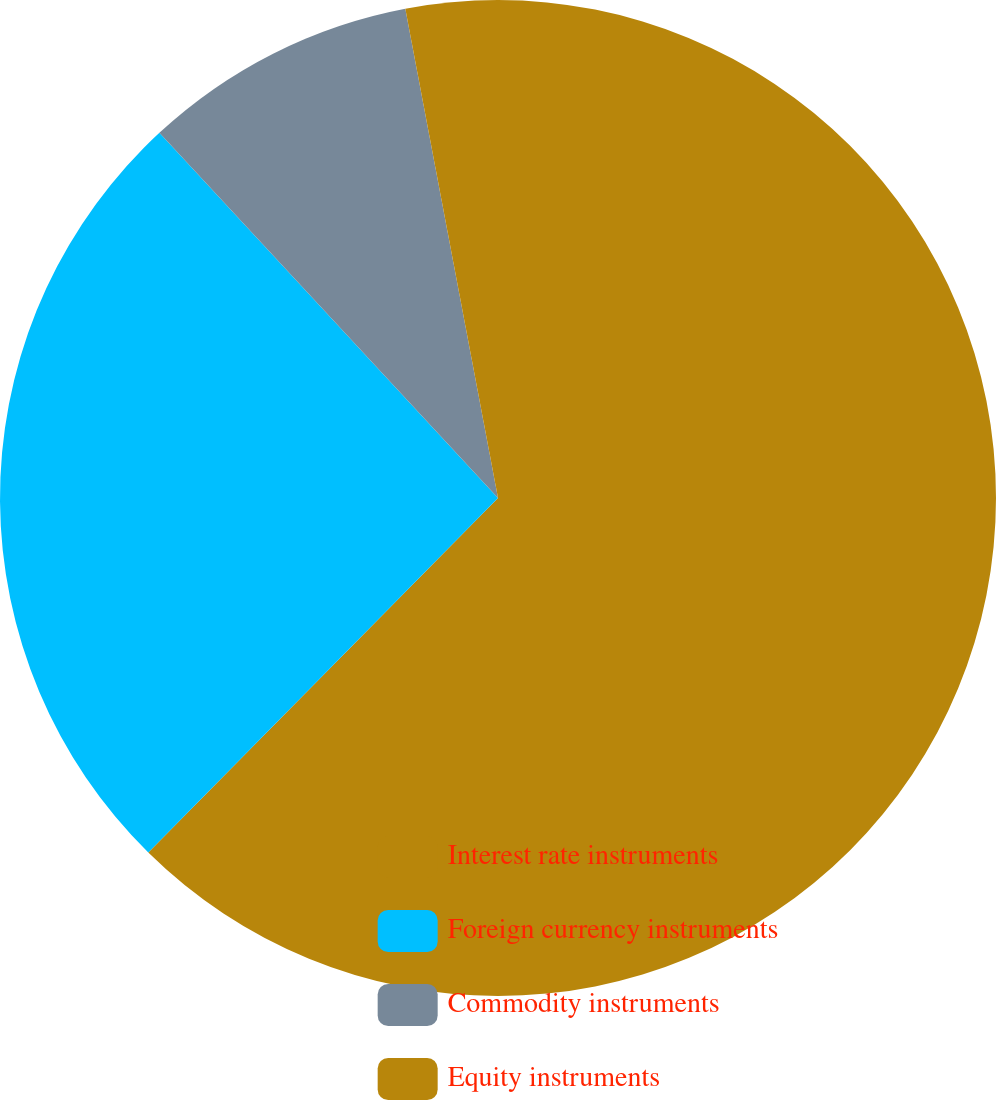Convert chart. <chart><loc_0><loc_0><loc_500><loc_500><pie_chart><fcel>Interest rate instruments<fcel>Foreign currency instruments<fcel>Commodity instruments<fcel>Equity instruments<nl><fcel>62.39%<fcel>25.71%<fcel>8.92%<fcel>2.98%<nl></chart> 